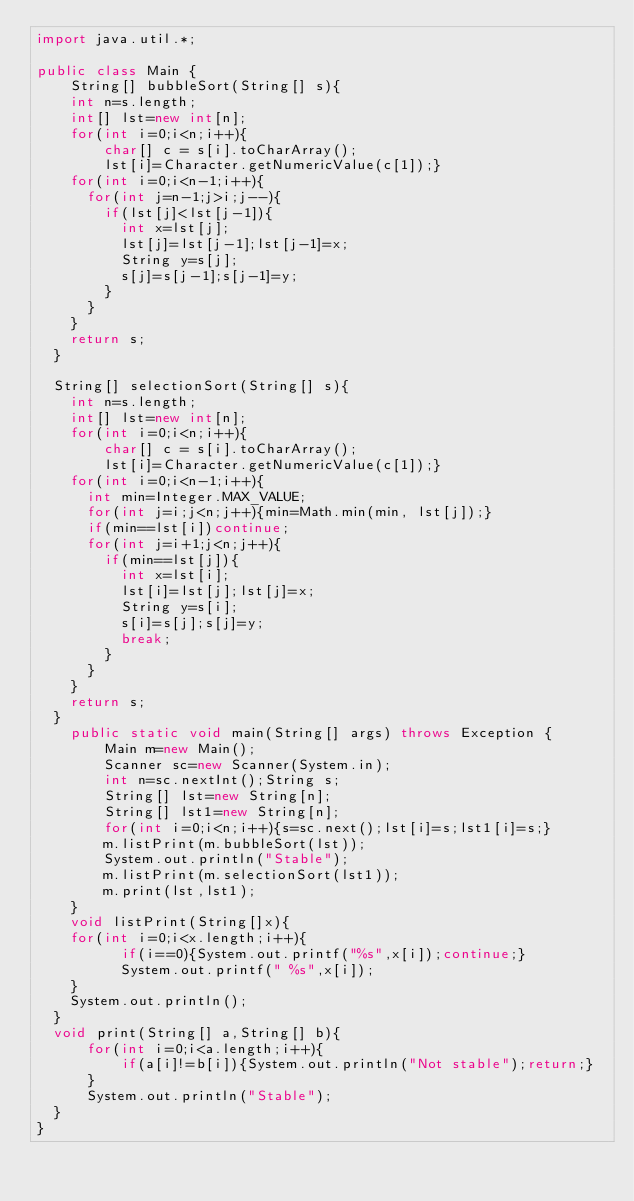Convert code to text. <code><loc_0><loc_0><loc_500><loc_500><_Java_>import java.util.*;

public class Main {
    String[] bubbleSort(String[] s){
		int n=s.length;
		int[] lst=new int[n];
		for(int i=0;i<n;i++){
		    char[] c = s[i].toCharArray();
		    lst[i]=Character.getNumericValue(c[1]);}
		for(int i=0;i<n-1;i++){
			for(int j=n-1;j>i;j--){
				if(lst[j]<lst[j-1]){
					int x=lst[j];
					lst[j]=lst[j-1];lst[j-1]=x;
					String y=s[j];
					s[j]=s[j-1];s[j-1]=y;
				}
			}
		}
		return s;
	}
	
	String[] selectionSort(String[] s){
		int n=s.length;
		int[] lst=new int[n];
		for(int i=0;i<n;i++){
		    char[] c = s[i].toCharArray();
		    lst[i]=Character.getNumericValue(c[1]);}
		for(int i=0;i<n-1;i++){
			int min=Integer.MAX_VALUE;
			for(int j=i;j<n;j++){min=Math.min(min, lst[j]);}
			if(min==lst[i])continue;
			for(int j=i+1;j<n;j++){
				if(min==lst[j]){
					int x=lst[i];
					lst[i]=lst[j];lst[j]=x;
					String y=s[i];
					s[i]=s[j];s[j]=y;
					break;
				}
			}
		}
		return s;
	}
    public static void main(String[] args) throws Exception {
        Main m=new Main();
        Scanner sc=new Scanner(System.in);
        int n=sc.nextInt();String s;
        String[] lst=new String[n];
        String[] lst1=new String[n];
        for(int i=0;i<n;i++){s=sc.next();lst[i]=s;lst1[i]=s;}
        m.listPrint(m.bubbleSort(lst));
        System.out.println("Stable");
        m.listPrint(m.selectionSort(lst1));
        m.print(lst,lst1);
    }
    void listPrint(String[]x){
		for(int i=0;i<x.length;i++){
	        if(i==0){System.out.printf("%s",x[i]);continue;}
	        System.out.printf(" %s",x[i]);
		}
		System.out.println();
	}
	void print(String[] a,String[] b){
	    for(int i=0;i<a.length;i++){
	        if(a[i]!=b[i]){System.out.println("Not stable");return;}
	    }
	    System.out.println("Stable");
	}
}
</code> 